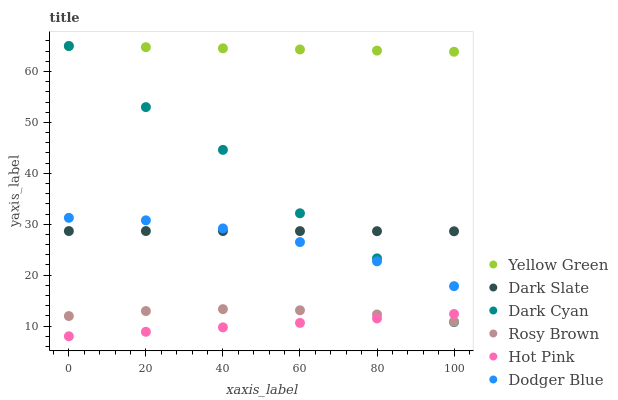Does Hot Pink have the minimum area under the curve?
Answer yes or no. Yes. Does Yellow Green have the maximum area under the curve?
Answer yes or no. Yes. Does Rosy Brown have the minimum area under the curve?
Answer yes or no. No. Does Rosy Brown have the maximum area under the curve?
Answer yes or no. No. Is Hot Pink the smoothest?
Answer yes or no. Yes. Is Dark Cyan the roughest?
Answer yes or no. Yes. Is Yellow Green the smoothest?
Answer yes or no. No. Is Yellow Green the roughest?
Answer yes or no. No. Does Hot Pink have the lowest value?
Answer yes or no. Yes. Does Rosy Brown have the lowest value?
Answer yes or no. No. Does Dark Cyan have the highest value?
Answer yes or no. Yes. Does Rosy Brown have the highest value?
Answer yes or no. No. Is Hot Pink less than Yellow Green?
Answer yes or no. Yes. Is Dark Slate greater than Rosy Brown?
Answer yes or no. Yes. Does Dark Cyan intersect Yellow Green?
Answer yes or no. Yes. Is Dark Cyan less than Yellow Green?
Answer yes or no. No. Is Dark Cyan greater than Yellow Green?
Answer yes or no. No. Does Hot Pink intersect Yellow Green?
Answer yes or no. No. 